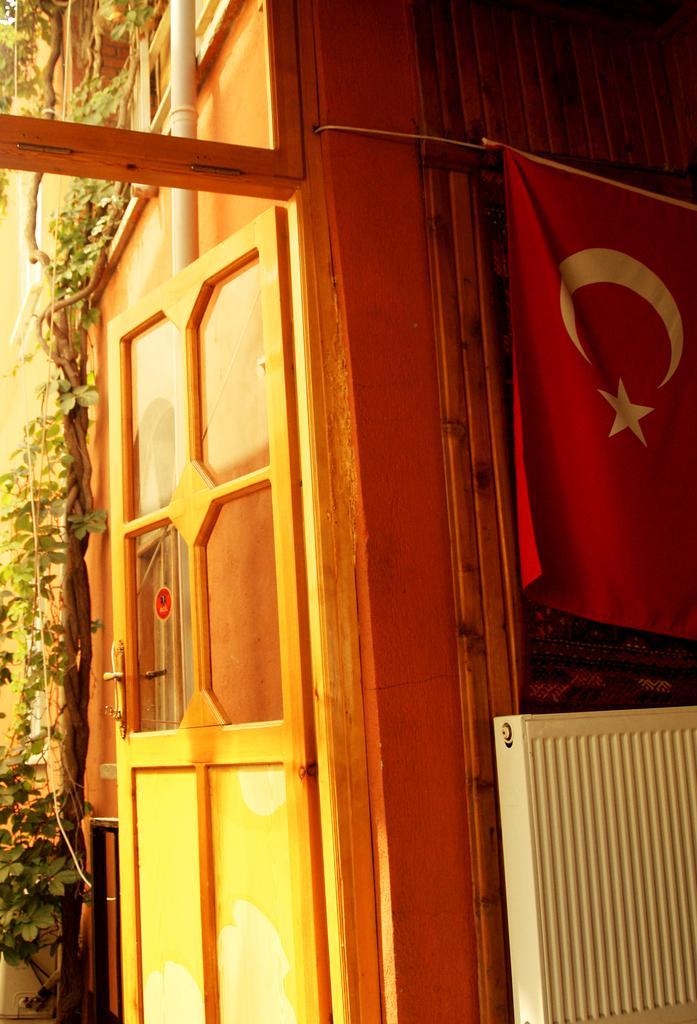In one or two sentences, can you explain what this image depicts? In this image I can see the door which is yellow and orange in color, a flag which is red and white in color, a pipe and a tree. I can see a white colored object. 